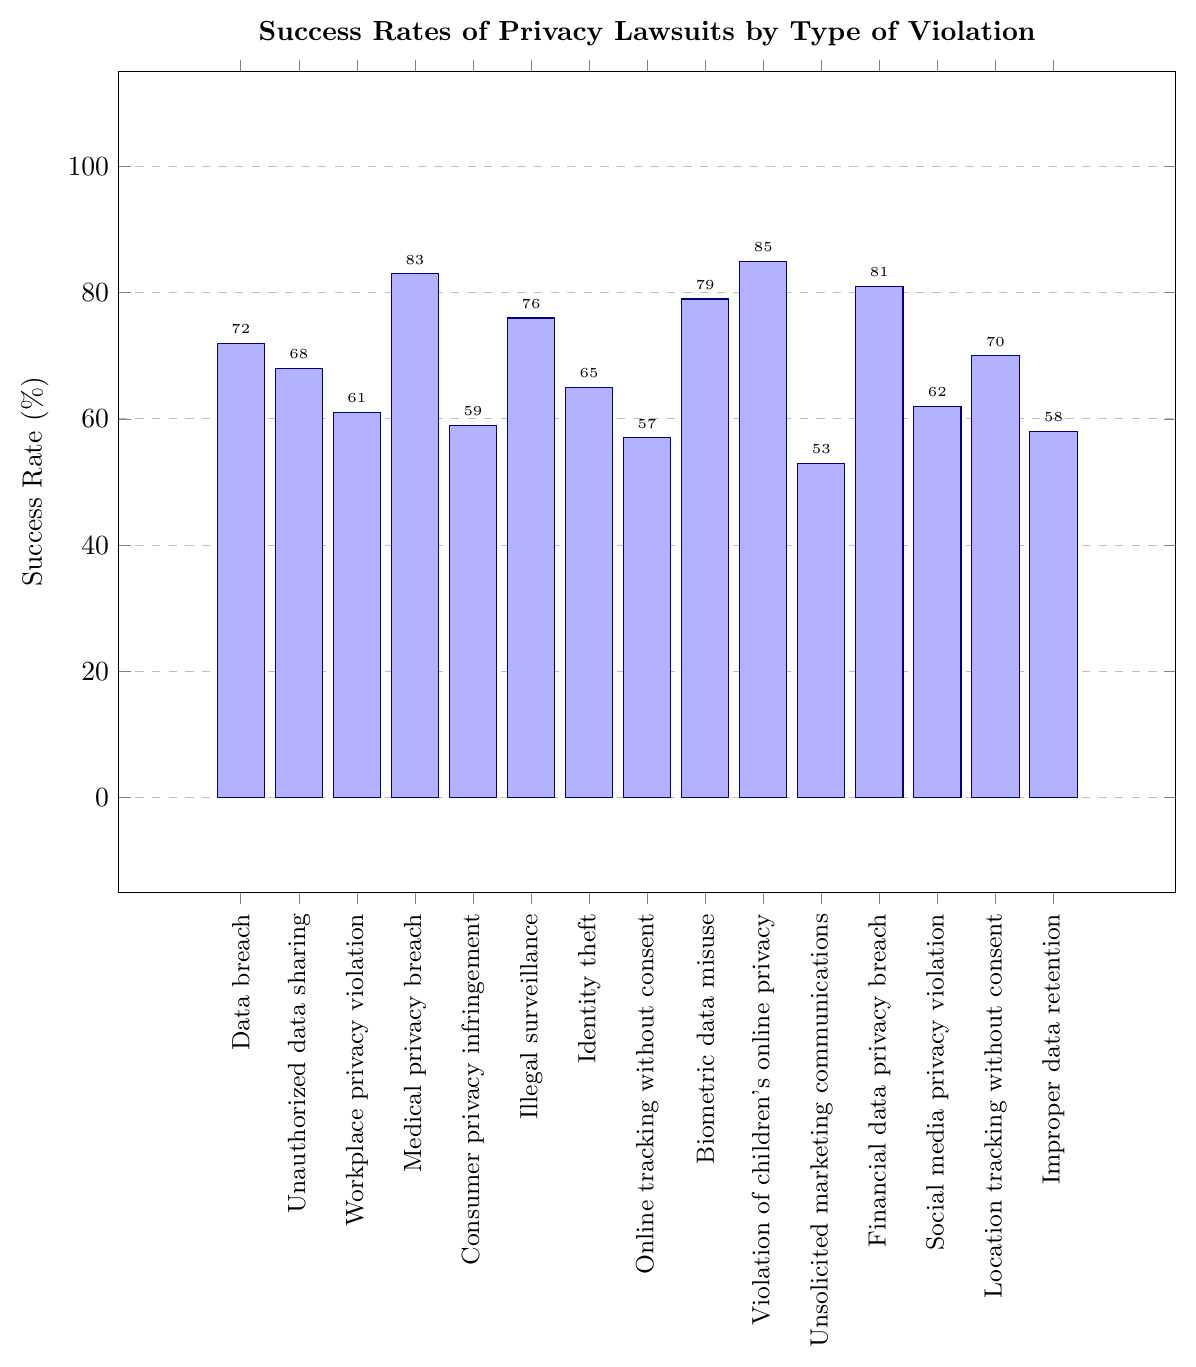What's the success rate of privacy lawsuits for Medical Privacy Breach? The bar labeled 'Medical privacy breach' is at the 83% mark on the y-axis, indicating the success rate.
Answer: 83% What is the average success rate of privacy lawsuits for Data Breach, Unauthorized Data Sharing, and Workplace Privacy Violation? The success rates are 72%, 68%, and 61% respectively. Their average is calculated as (72+68+61)/3 = 67%.
Answer: 67% How does the success rate of Financial Data Privacy Breach compare to that of Identity Theft? The success rate of Financial Data Privacy Breach is 81%, while that of Identity Theft is 65%. The financial data breach has a higher success rate.
Answer: Financial Data Privacy Breach is higher Which type of privacy violation has the highest success rate in lawsuits? By observing the heights of the bars, 'Violation of children's online privacy' has the highest success rate at 85%.
Answer: Violation of children's online privacy What is the difference in success rates between Online Tracking Without Consent and Biometric Data Misuse? The success rates are 57% for Online Tracking Without Consent and 79% for Biometric Data Misuse. The difference is 79% - 57% = 22%.
Answer: 22% What is the median success rate of all listed privacy violations? To find the median, list all success rates in ascending order: 53, 57, 58, 59, 61, 62, 65, 68, 70, 72, 76, 79, 81, 83, 85. The median value is the 8th value in this list, which is 68%.
Answer: 68% Compare the success rates of Social Media Privacy Violation and Location Tracking Without Consent. Which has a higher rate? The success rate of Social Media Privacy Violation is 62% and for Location Tracking Without Consent is 70%. Location Tracking Without Consent has a higher success rate.
Answer: Location Tracking Without Consent is higher What is the range of success rates for all types of privacy violations? The minimum success rate is 53% and the maximum is 85%. The range is 85% - 53% = 32%.
Answer: 32% Which privacy violation has a lower success rate: Consumer Privacy Infringement or Unauthorized Data Sharing? The success rate for Consumer Privacy Infringement is 59%, and for Unauthorized Data Sharing, it is 68%. Consumer Privacy Infringement has a lower success rate.
Answer: Consumer Privacy Infringement is lower What is the sum of success rates for Illegal Surveillance, Identity Theft, and Online Tracking Without Consent? The success rates are 76%, 65%, and 57%, respectively. The sum is 76 + 65 + 57 = 198%.
Answer: 198% 